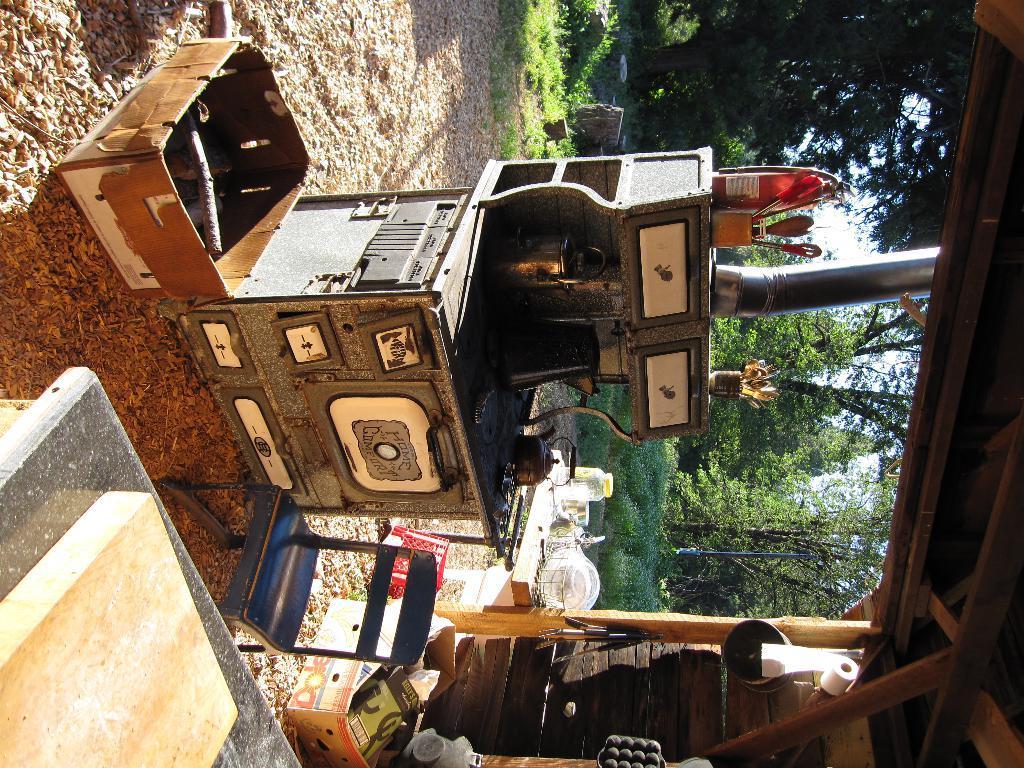Please provide a concise description of this image. In this image, we can see cupboard, carton boxes, chair, marble, board and shed. Here there is a tissue roll and few objects. Background we can see trees, plants and sky. On the right side of the image, we can see a pipe. 